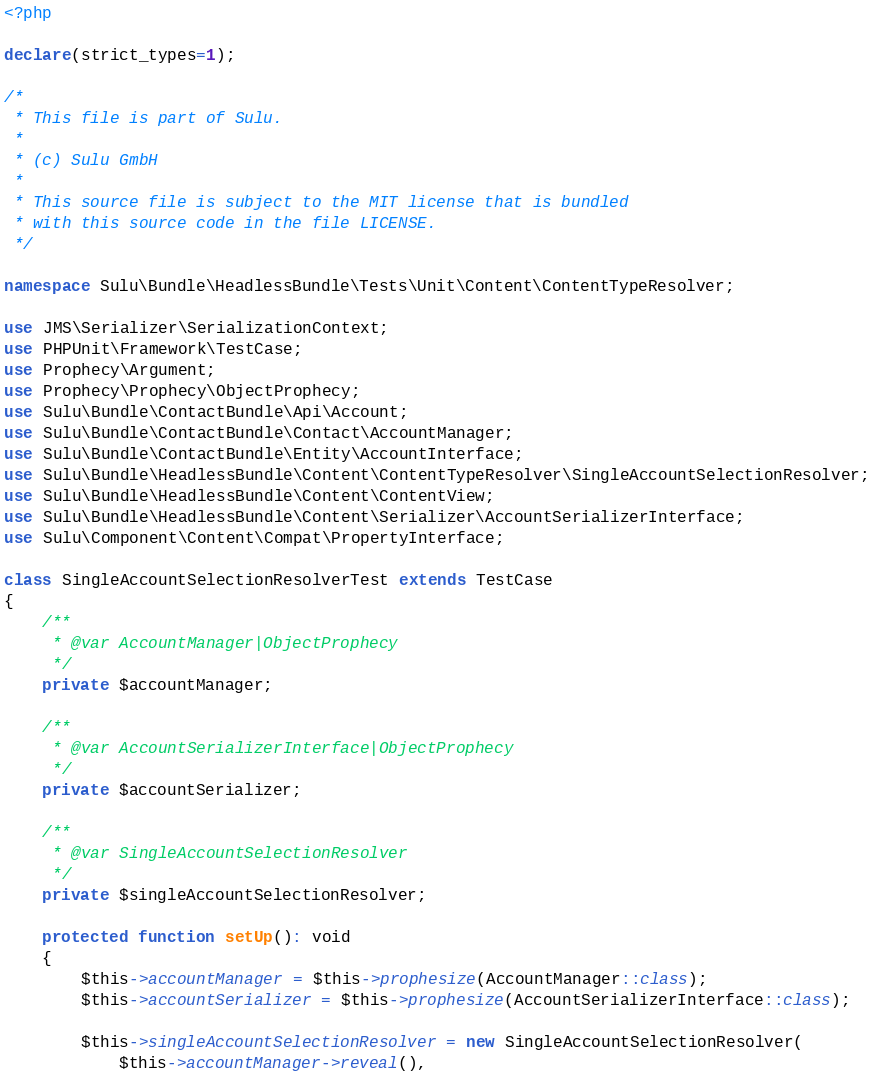<code> <loc_0><loc_0><loc_500><loc_500><_PHP_><?php

declare(strict_types=1);

/*
 * This file is part of Sulu.
 *
 * (c) Sulu GmbH
 *
 * This source file is subject to the MIT license that is bundled
 * with this source code in the file LICENSE.
 */

namespace Sulu\Bundle\HeadlessBundle\Tests\Unit\Content\ContentTypeResolver;

use JMS\Serializer\SerializationContext;
use PHPUnit\Framework\TestCase;
use Prophecy\Argument;
use Prophecy\Prophecy\ObjectProphecy;
use Sulu\Bundle\ContactBundle\Api\Account;
use Sulu\Bundle\ContactBundle\Contact\AccountManager;
use Sulu\Bundle\ContactBundle\Entity\AccountInterface;
use Sulu\Bundle\HeadlessBundle\Content\ContentTypeResolver\SingleAccountSelectionResolver;
use Sulu\Bundle\HeadlessBundle\Content\ContentView;
use Sulu\Bundle\HeadlessBundle\Content\Serializer\AccountSerializerInterface;
use Sulu\Component\Content\Compat\PropertyInterface;

class SingleAccountSelectionResolverTest extends TestCase
{
    /**
     * @var AccountManager|ObjectProphecy
     */
    private $accountManager;

    /**
     * @var AccountSerializerInterface|ObjectProphecy
     */
    private $accountSerializer;

    /**
     * @var SingleAccountSelectionResolver
     */
    private $singleAccountSelectionResolver;

    protected function setUp(): void
    {
        $this->accountManager = $this->prophesize(AccountManager::class);
        $this->accountSerializer = $this->prophesize(AccountSerializerInterface::class);

        $this->singleAccountSelectionResolver = new SingleAccountSelectionResolver(
            $this->accountManager->reveal(),</code> 